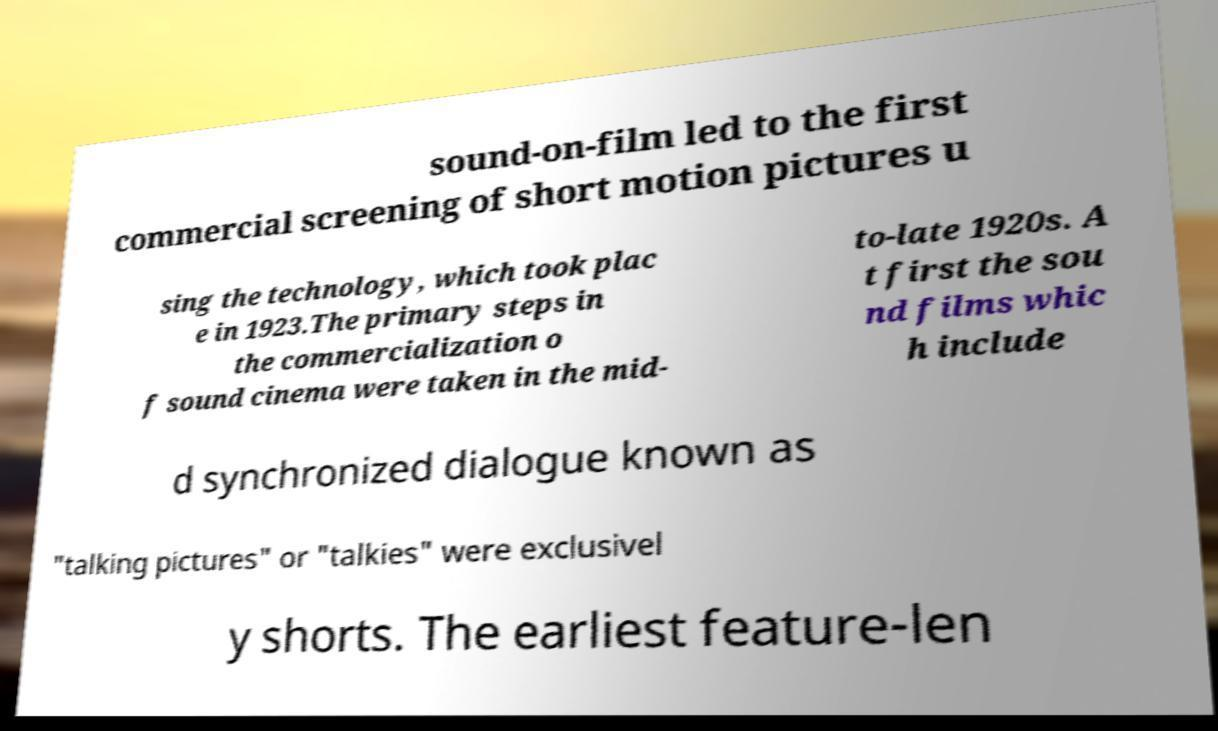Could you assist in decoding the text presented in this image and type it out clearly? sound-on-film led to the first commercial screening of short motion pictures u sing the technology, which took plac e in 1923.The primary steps in the commercialization o f sound cinema were taken in the mid- to-late 1920s. A t first the sou nd films whic h include d synchronized dialogue known as "talking pictures" or "talkies" were exclusivel y shorts. The earliest feature-len 